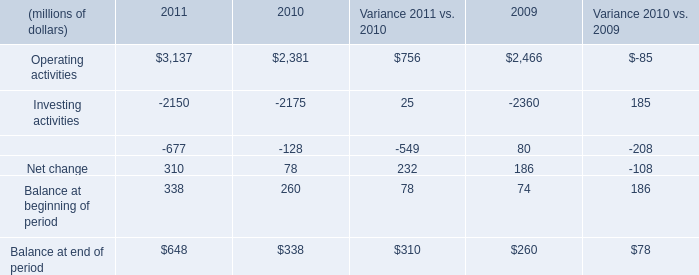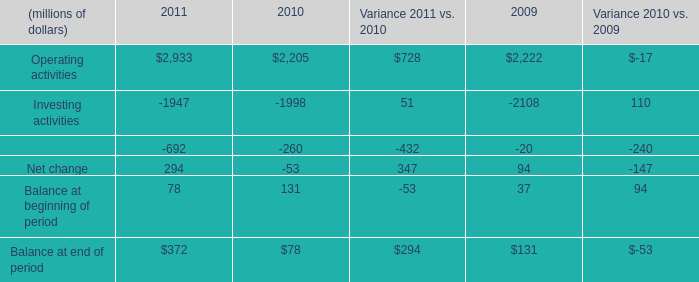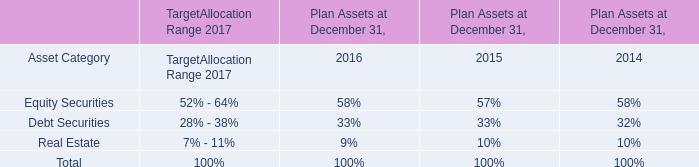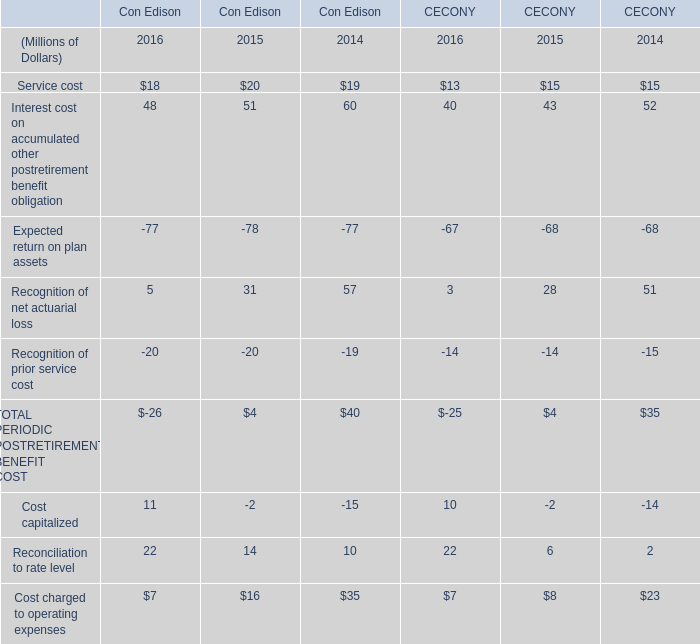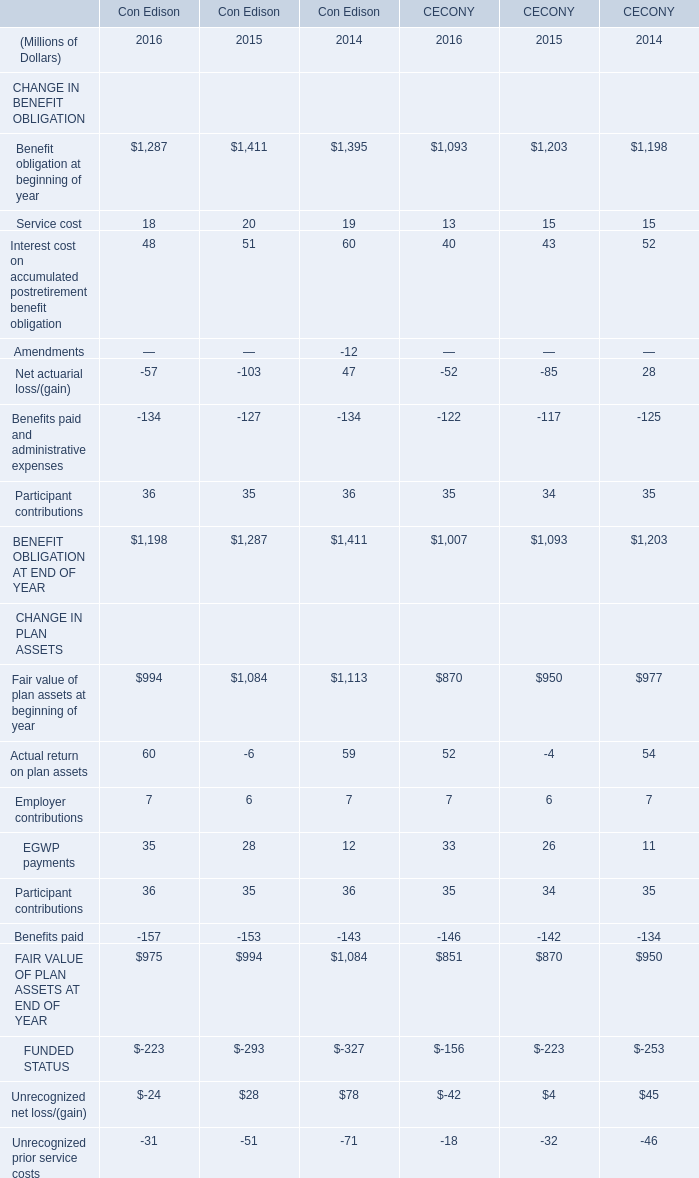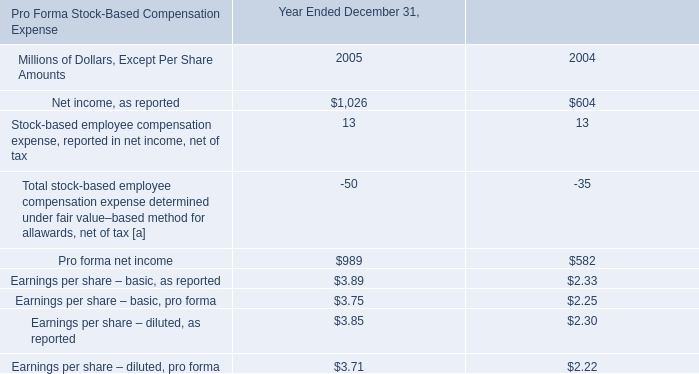How much of PERIODIC POSTRETIREMENT BENEFIT COST of Con Edison is there in 2016 without Service cost and Interest cost on accumulated other postretirement benefit obligation? (in million) 
Computations: ((-77 + 5) + -20)
Answer: -92.0. 